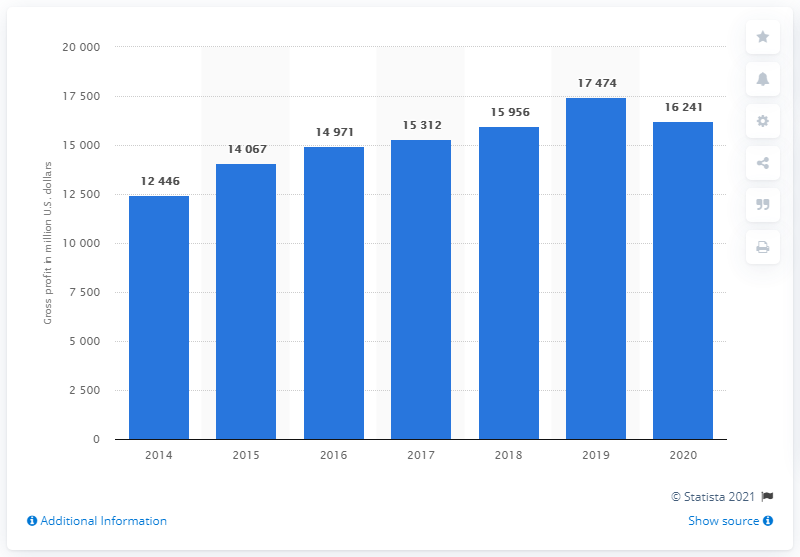What was Nike's global gross profit in dollars in 2020?
 16241 